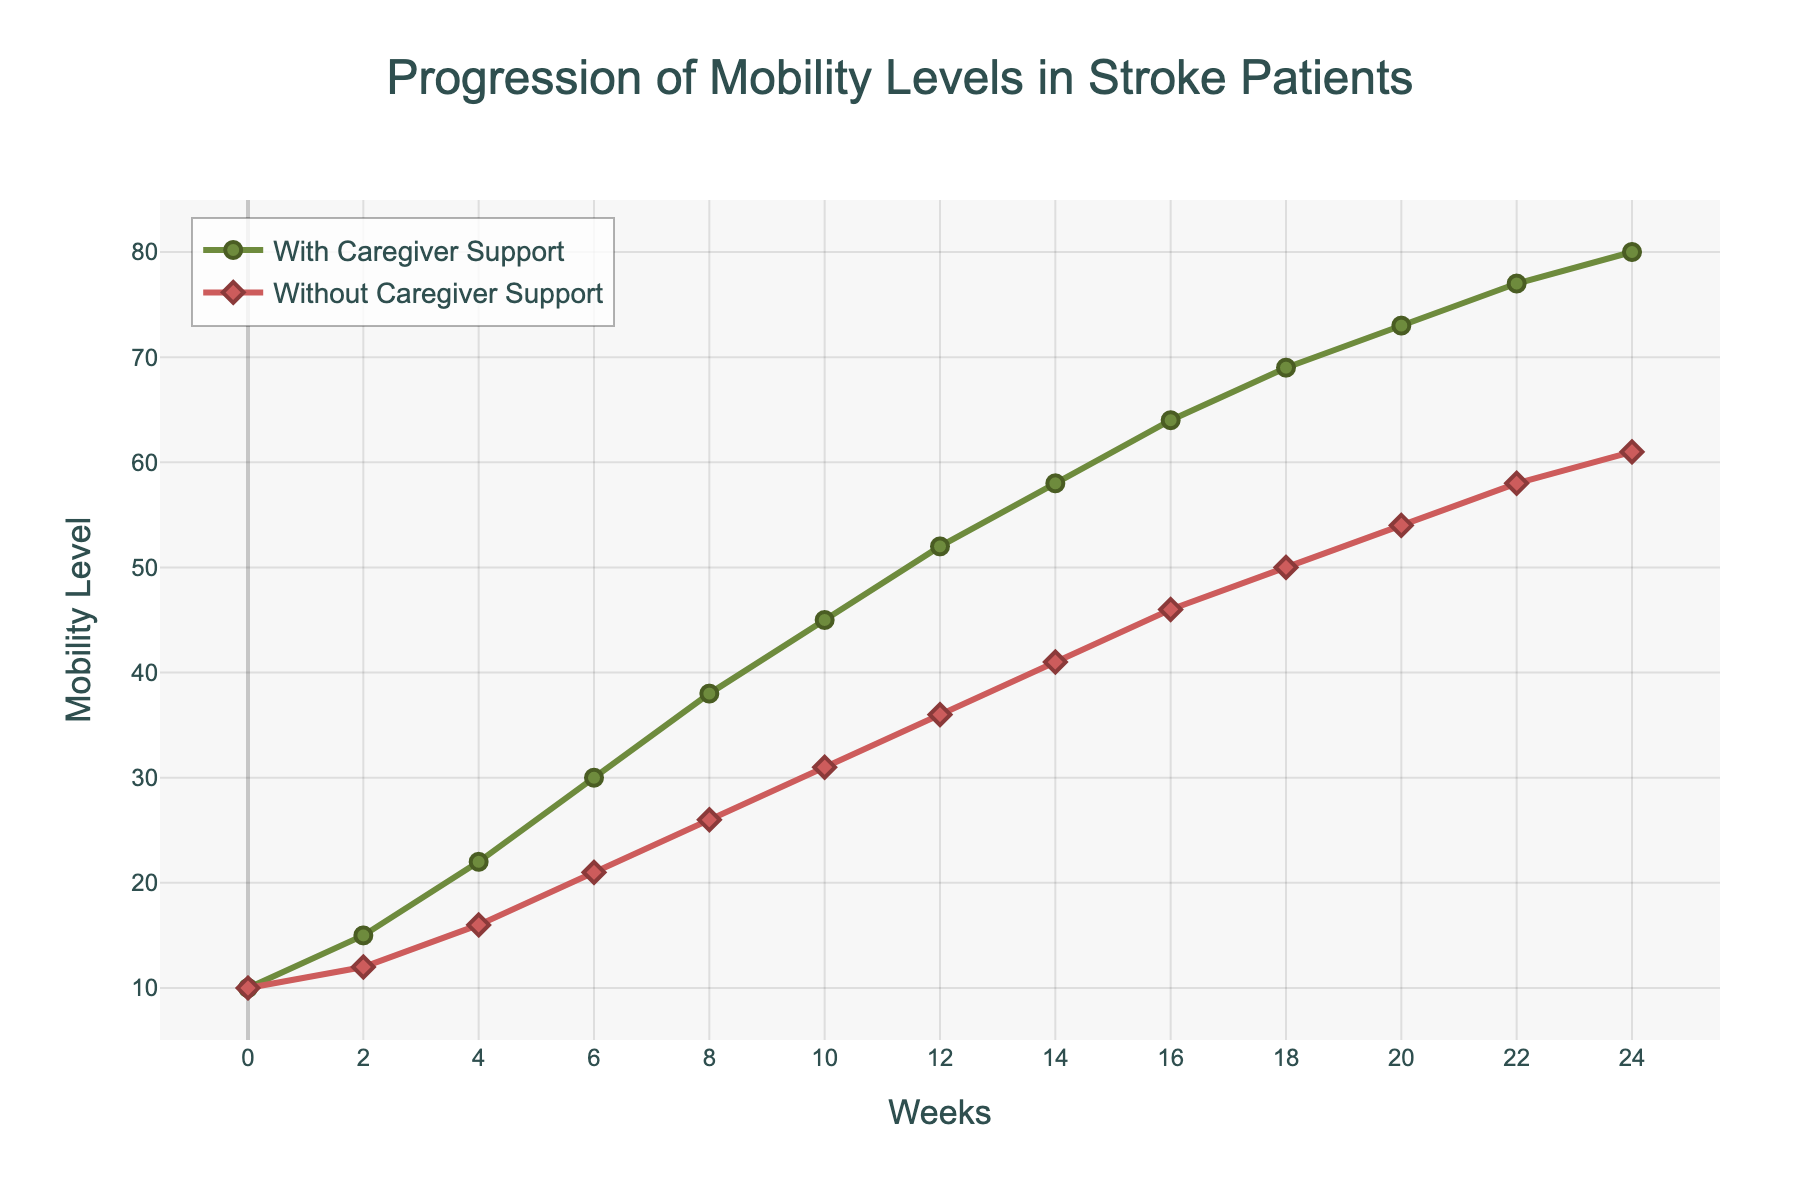What is the initial mobility level of stroke patients with consistent family caregiver support? The initial mobility level for stroke patients with consistent family caregiver support can be found at the starting point (Week 0) on the y-axis of the green line.
Answer: 10 By how much does the mobility level increase for patients with family caregiver support from Week 0 to Week 8? Find the mobility level at Week 0 (10) and Week 8 (38) for patients with family caregiver support, then subtract the initial level from the Week 8 level: 38 - 10.
Answer: 28 After 6 months, what is the difference in mobility levels between patients with and without family caregiver support? Look at the mobility levels at Week 24 for both groups: 80 (with caregiver support) and 61 (without caregiver support). Subtract the value for patients without caregiver support from the value for patients with caregiver support: 80 - 61.
Answer: 19 Which group shows a steeper progression in mobility levels over the 24 weeks? Compare the steepness (slope) of the lines representing both groups over the entire period. The green (with caregiver support) line shows a steeper overall incline compared to the red (without caregiver support) line.
Answer: With caregiver support Which group reaches a mobility level of 50 first, and after how many weeks? Find where each line crosses the 50 on the y-axis. The green line (with caregiver support) reaches 50 at Week 18, while the red line (without caregiver support) reaches it at Week 20.
Answer: With caregiver support, 18 weeks What is the average mobility level for patients without family caregiver support from Week 0 to Week 24? Add the mobility levels for patients without family caregiver support at each data point: (10 + 12 + 16 + 21 + 26 + 31 + 36 + 41 + 46 + 50 + 54 + 58 + 61), then divide by the number of data points (13): Sum = 462; Average = 462 / 13.
Answer: 35.54 At Week 10, how much higher is the mobility level for patients with caregiver support compared to those without? Look at the mobility levels at Week 10: 45 (with caregiver support) and 31 (without caregiver support). Subtract the level for patients without caregiver support from the level for patients with caregiver support: 45 - 31.
Answer: 14 How does the rate of increase in mobility levels differ between the two groups in the first 6 weeks? Calculate the increase for each group in the first 6 weeks: With caregiver support is from 10 to 30 (increase of 20), without caregiver support is from 10 to 21 (increase of 11). Compare the increases.
Answer: The increase is higher for patients with caregiver support (20 vs. 11) How many weeks does it take for patients without caregiver support to reach a mobility level of 36? Look at the point on the red line that corresponds to a mobility level of 36 on the y-axis, which is at Week 12.
Answer: 12 weeks What color line represents the patients with consistent family caregiver support? The green line represents the patients with consistent family caregiver support.
Answer: Green 